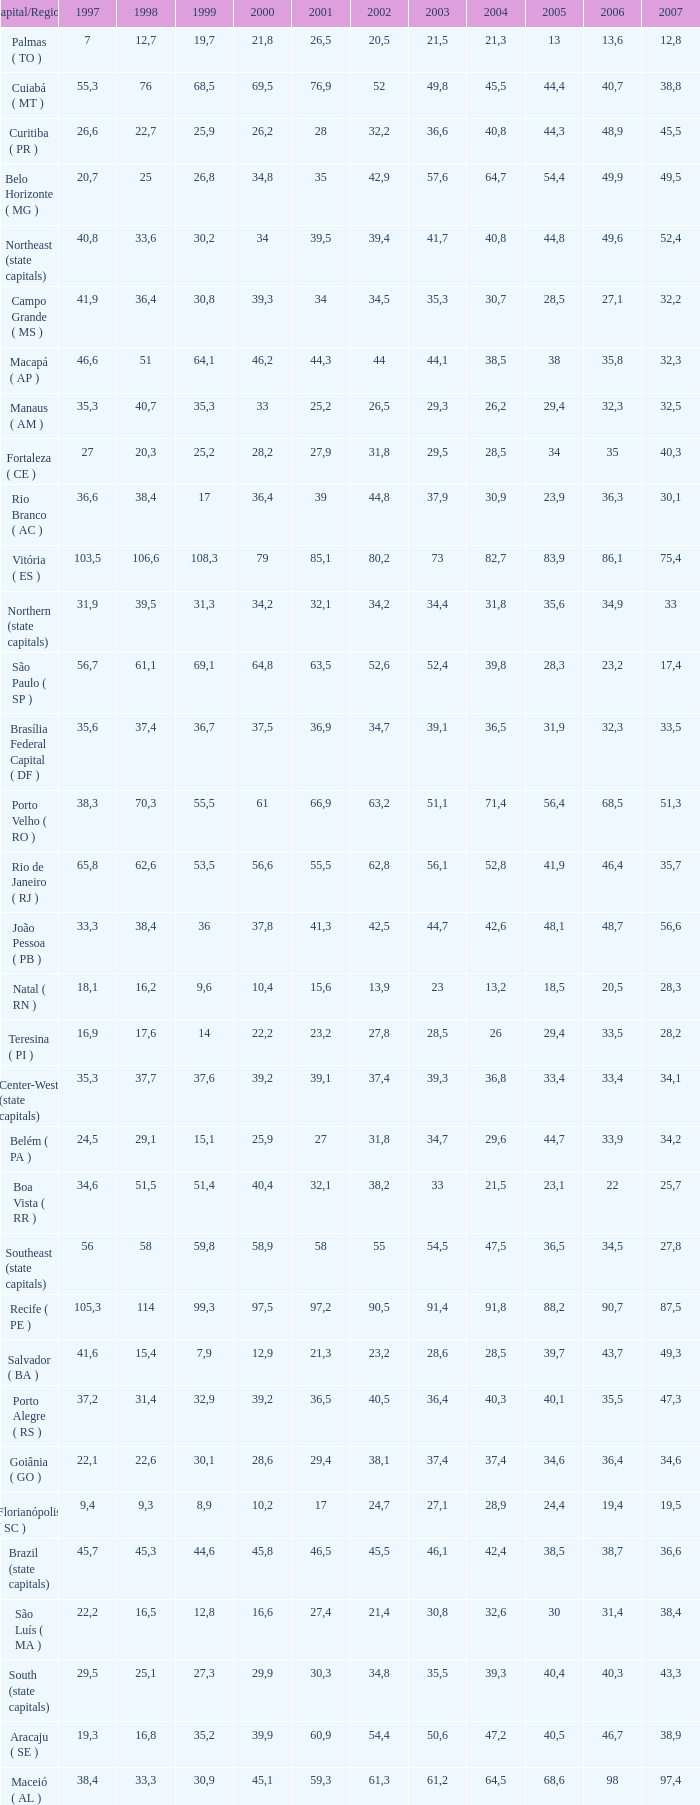What is the average 2000 that has a 1997 greater than 34,6, a 2006 greater than 38,7, and a 2998 less than 76? 41.92. 